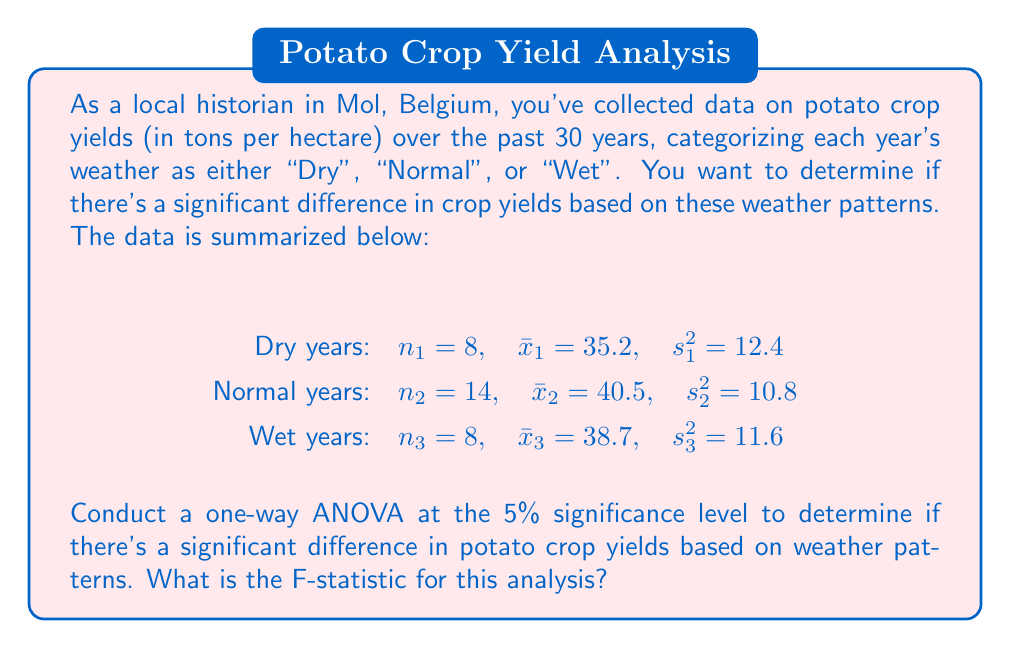What is the answer to this math problem? To conduct a one-way ANOVA, we need to calculate the F-statistic. The steps are as follows:

1. Calculate the total sum of squares (SST):
   $$SST = (n_1 - 1)s_1^2 + (n_2 - 1)s_2^2 + (n_3 - 1)s_3^2 + n_1(\bar{x}_1 - \bar{x})^2 + n_2(\bar{x}_2 - \bar{x})^2 + n_3(\bar{x}_3 - \bar{x})^2$$

2. Calculate the between-group sum of squares (SSB):
   $$SSB = n_1(\bar{x}_1 - \bar{x})^2 + n_2(\bar{x}_2 - \bar{x})^2 + n_3(\bar{x}_3 - \bar{x})^2$$

3. Calculate the within-group sum of squares (SSW):
   $$SSW = SST - SSB$$

4. Calculate the mean squares:
   $$MSB = \frac{SSB}{k-1}, \quad MSW = \frac{SSW}{N-k}$$
   where $k$ is the number of groups and $N$ is the total sample size.

5. Calculate the F-statistic:
   $$F = \frac{MSB}{MSW}$$

Let's proceed with the calculations:

First, we need to find the grand mean $\bar{x}$:
$$\bar{x} = \frac{n_1\bar{x}_1 + n_2\bar{x}_2 + n_3\bar{x}_3}{n_1 + n_2 + n_3} = \frac{8(35.2) + 14(40.5) + 8(38.7)}{30} = 38.56$$

Now we can calculate SST:
$$SST = 7(12.4) + 13(10.8) + 7(11.6) + 8(35.2 - 38.56)^2 + 14(40.5 - 38.56)^2 + 8(38.7 - 38.56)^2 = 324.8$$

For SSB:
$$SSB = 8(35.2 - 38.56)^2 + 14(40.5 - 38.56)^2 + 8(38.7 - 38.56)^2 = 160.3968$$

SSW:
$$SSW = SST - SSB = 324.8 - 160.3968 = 164.4032$$

Mean squares:
$$MSB = \frac{SSB}{k-1} = \frac{160.3968}{2} = 80.1984$$
$$MSW = \frac{SSW}{N-k} = \frac{164.4032}{27} = 6.0890$$

Finally, the F-statistic:
$$F = \frac{MSB}{MSW} = \frac{80.1984}{6.0890} = 13.1710$$
Answer: The F-statistic for this one-way ANOVA is approximately 13.1710. 